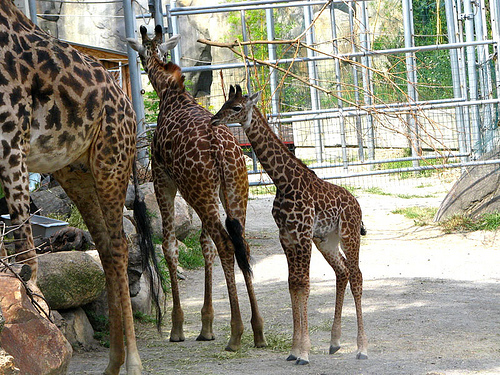Can you describe the habitat in which these giraffes are living? The habitat appears to be a spacious enclosure with a mixture of grass, rocks, and a few trees. The encircling structure with pipes and platforms suggests it is likely part of a zoo designed to emulate a savanna-like environment. 